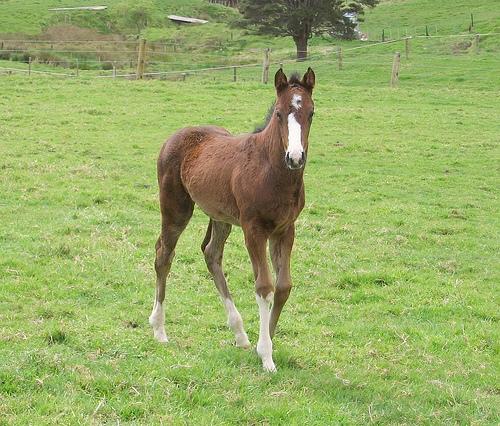How old is the horse?
Keep it brief. Young. Is this animal an adult?
Quick response, please. No. What color are the markings on the horse's legs?
Keep it brief. White. Is this a baby?
Short answer required. Yes. 